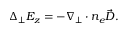<formula> <loc_0><loc_0><loc_500><loc_500>\begin{array} { r } { \Delta _ { \perp } E _ { z } = - \nabla _ { \perp } \cdot n _ { e } \vec { D } . } \end{array}</formula> 